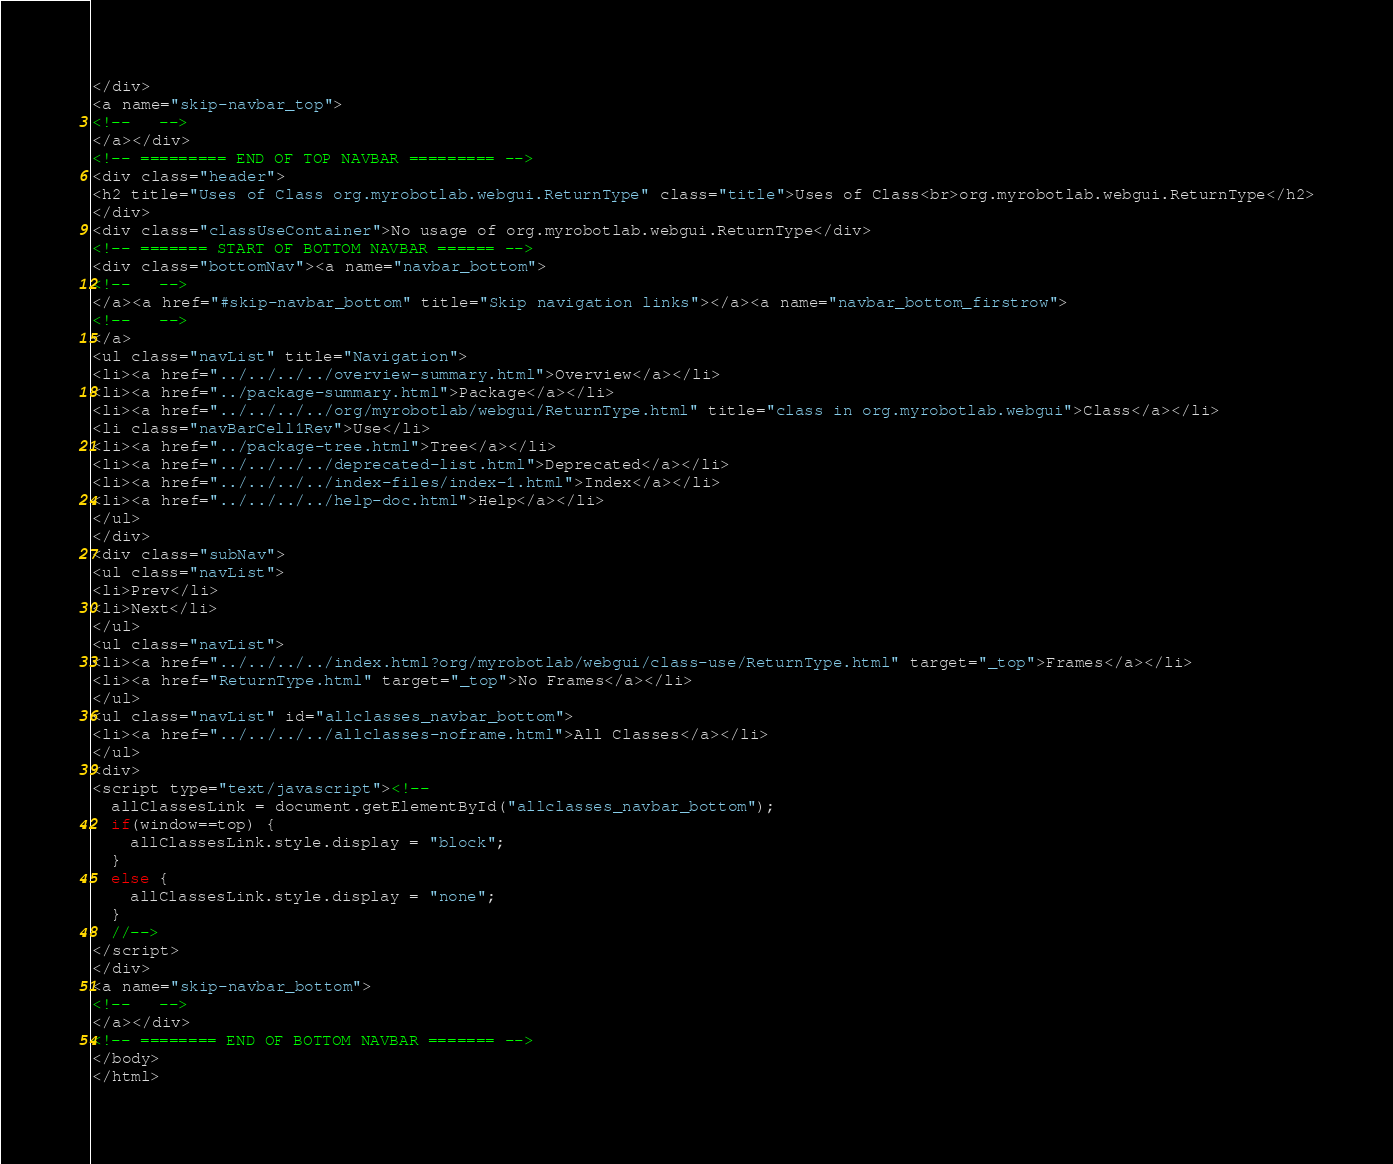<code> <loc_0><loc_0><loc_500><loc_500><_HTML_></div>
<a name="skip-navbar_top">
<!--   -->
</a></div>
<!-- ========= END OF TOP NAVBAR ========= -->
<div class="header">
<h2 title="Uses of Class org.myrobotlab.webgui.ReturnType" class="title">Uses of Class<br>org.myrobotlab.webgui.ReturnType</h2>
</div>
<div class="classUseContainer">No usage of org.myrobotlab.webgui.ReturnType</div>
<!-- ======= START OF BOTTOM NAVBAR ====== -->
<div class="bottomNav"><a name="navbar_bottom">
<!--   -->
</a><a href="#skip-navbar_bottom" title="Skip navigation links"></a><a name="navbar_bottom_firstrow">
<!--   -->
</a>
<ul class="navList" title="Navigation">
<li><a href="../../../../overview-summary.html">Overview</a></li>
<li><a href="../package-summary.html">Package</a></li>
<li><a href="../../../../org/myrobotlab/webgui/ReturnType.html" title="class in org.myrobotlab.webgui">Class</a></li>
<li class="navBarCell1Rev">Use</li>
<li><a href="../package-tree.html">Tree</a></li>
<li><a href="../../../../deprecated-list.html">Deprecated</a></li>
<li><a href="../../../../index-files/index-1.html">Index</a></li>
<li><a href="../../../../help-doc.html">Help</a></li>
</ul>
</div>
<div class="subNav">
<ul class="navList">
<li>Prev</li>
<li>Next</li>
</ul>
<ul class="navList">
<li><a href="../../../../index.html?org/myrobotlab/webgui/class-use/ReturnType.html" target="_top">Frames</a></li>
<li><a href="ReturnType.html" target="_top">No Frames</a></li>
</ul>
<ul class="navList" id="allclasses_navbar_bottom">
<li><a href="../../../../allclasses-noframe.html">All Classes</a></li>
</ul>
<div>
<script type="text/javascript"><!--
  allClassesLink = document.getElementById("allclasses_navbar_bottom");
  if(window==top) {
    allClassesLink.style.display = "block";
  }
  else {
    allClassesLink.style.display = "none";
  }
  //-->
</script>
</div>
<a name="skip-navbar_bottom">
<!--   -->
</a></div>
<!-- ======== END OF BOTTOM NAVBAR ======= -->
</body>
</html>
</code> 